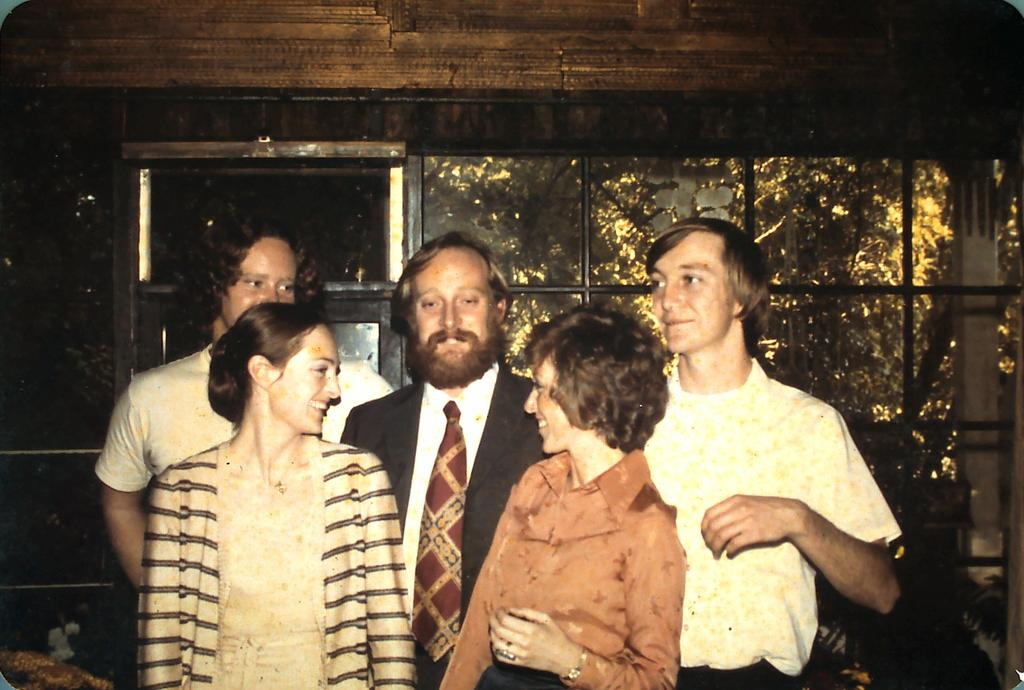How many people are standing in the foreground of the image? There are two women and three men standing in the foreground of the image. What is located in the background of the image? There is a glass wall and a window in the background of the image. What can be seen through the glass and window in the background of the image? Trees are visible through the glass and window in the background of the image. What type of locket is hanging from the tree in the image? There is no locket present in the image; it only features people in the foreground and trees visible through the glass and window in the background. 